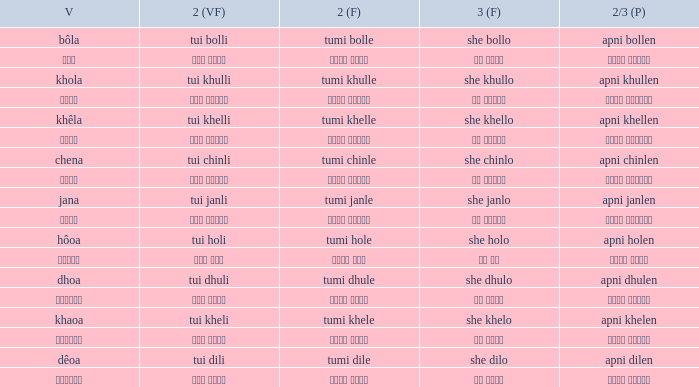What is the 3rd for the 2nd Tui Dhuli? She dhulo. 